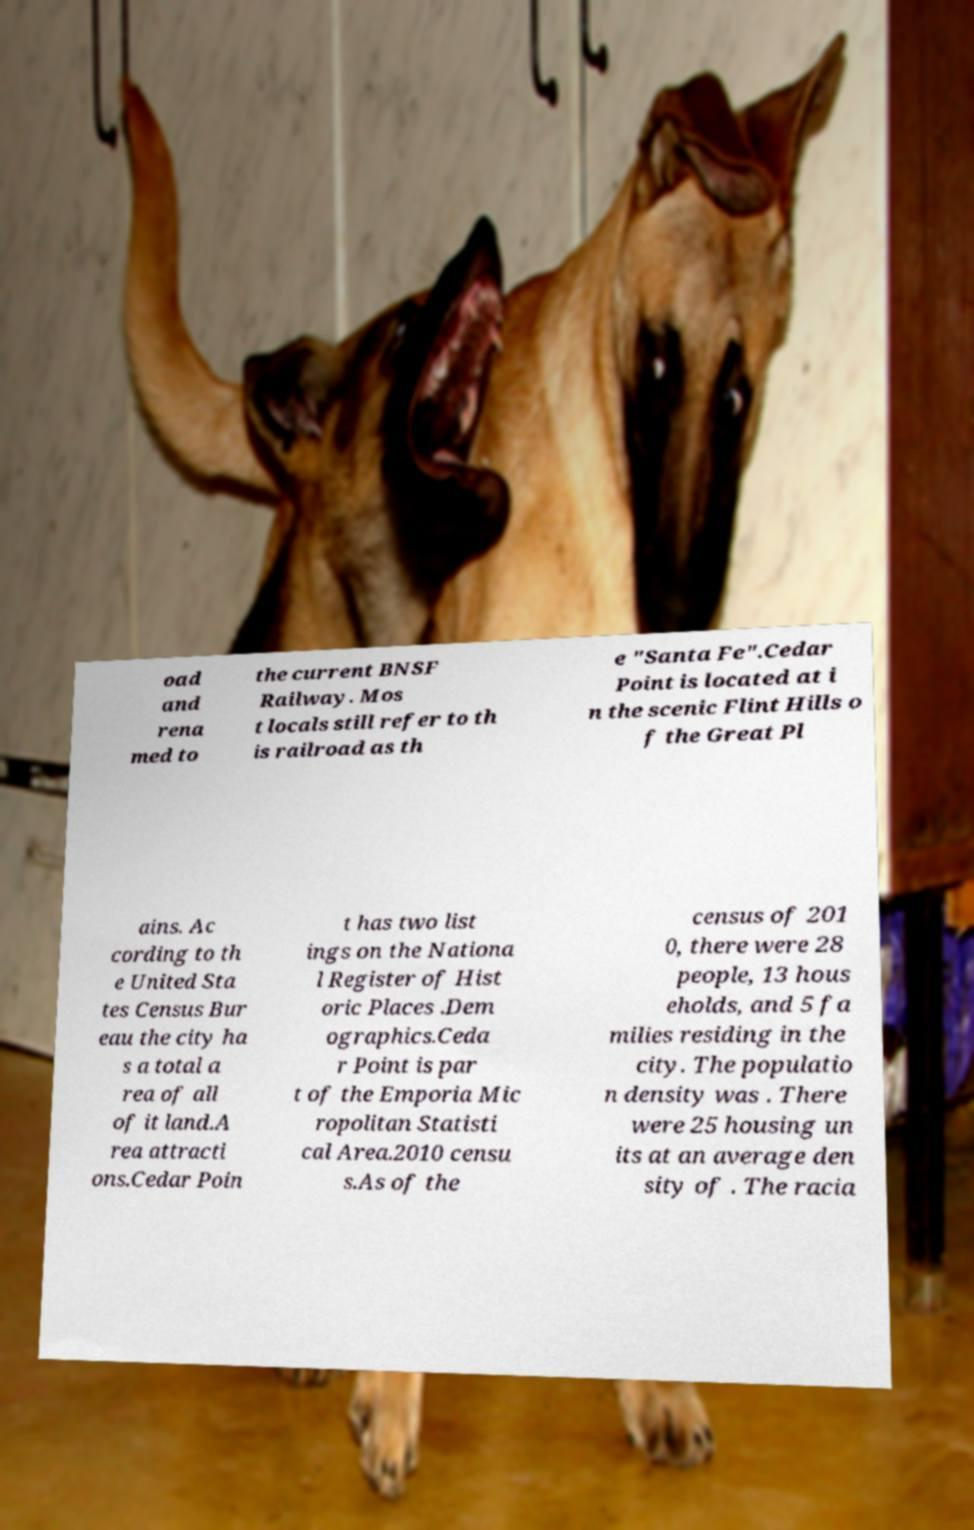Could you assist in decoding the text presented in this image and type it out clearly? oad and rena med to the current BNSF Railway. Mos t locals still refer to th is railroad as th e "Santa Fe".Cedar Point is located at i n the scenic Flint Hills o f the Great Pl ains. Ac cording to th e United Sta tes Census Bur eau the city ha s a total a rea of all of it land.A rea attracti ons.Cedar Poin t has two list ings on the Nationa l Register of Hist oric Places .Dem ographics.Ceda r Point is par t of the Emporia Mic ropolitan Statisti cal Area.2010 censu s.As of the census of 201 0, there were 28 people, 13 hous eholds, and 5 fa milies residing in the city. The populatio n density was . There were 25 housing un its at an average den sity of . The racia 